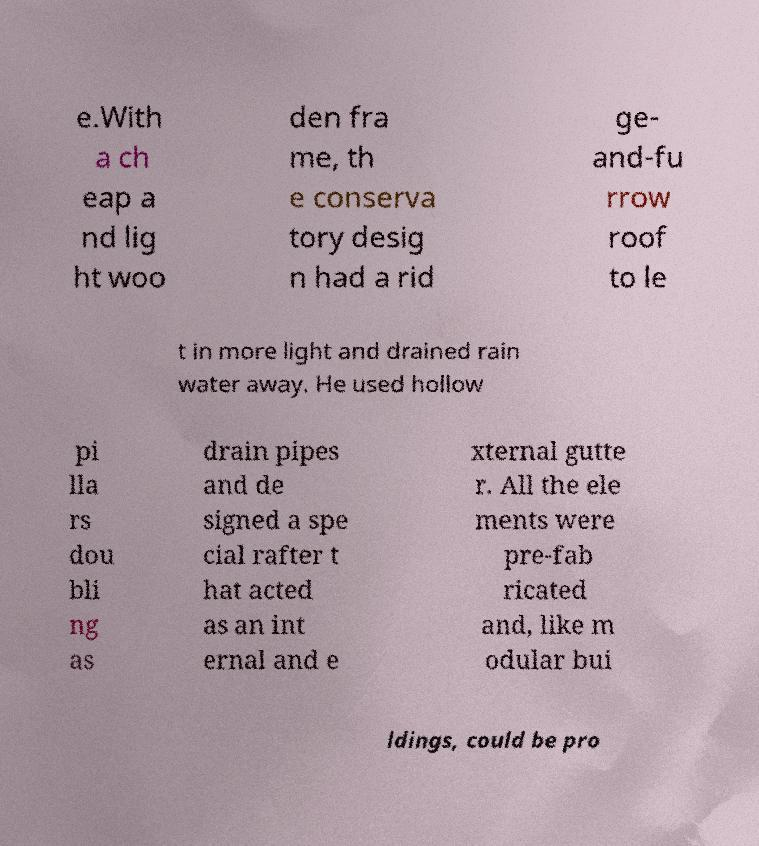Can you accurately transcribe the text from the provided image for me? e.With a ch eap a nd lig ht woo den fra me, th e conserva tory desig n had a rid ge- and-fu rrow roof to le t in more light and drained rain water away. He used hollow pi lla rs dou bli ng as drain pipes and de signed a spe cial rafter t hat acted as an int ernal and e xternal gutte r. All the ele ments were pre-fab ricated and, like m odular bui ldings, could be pro 